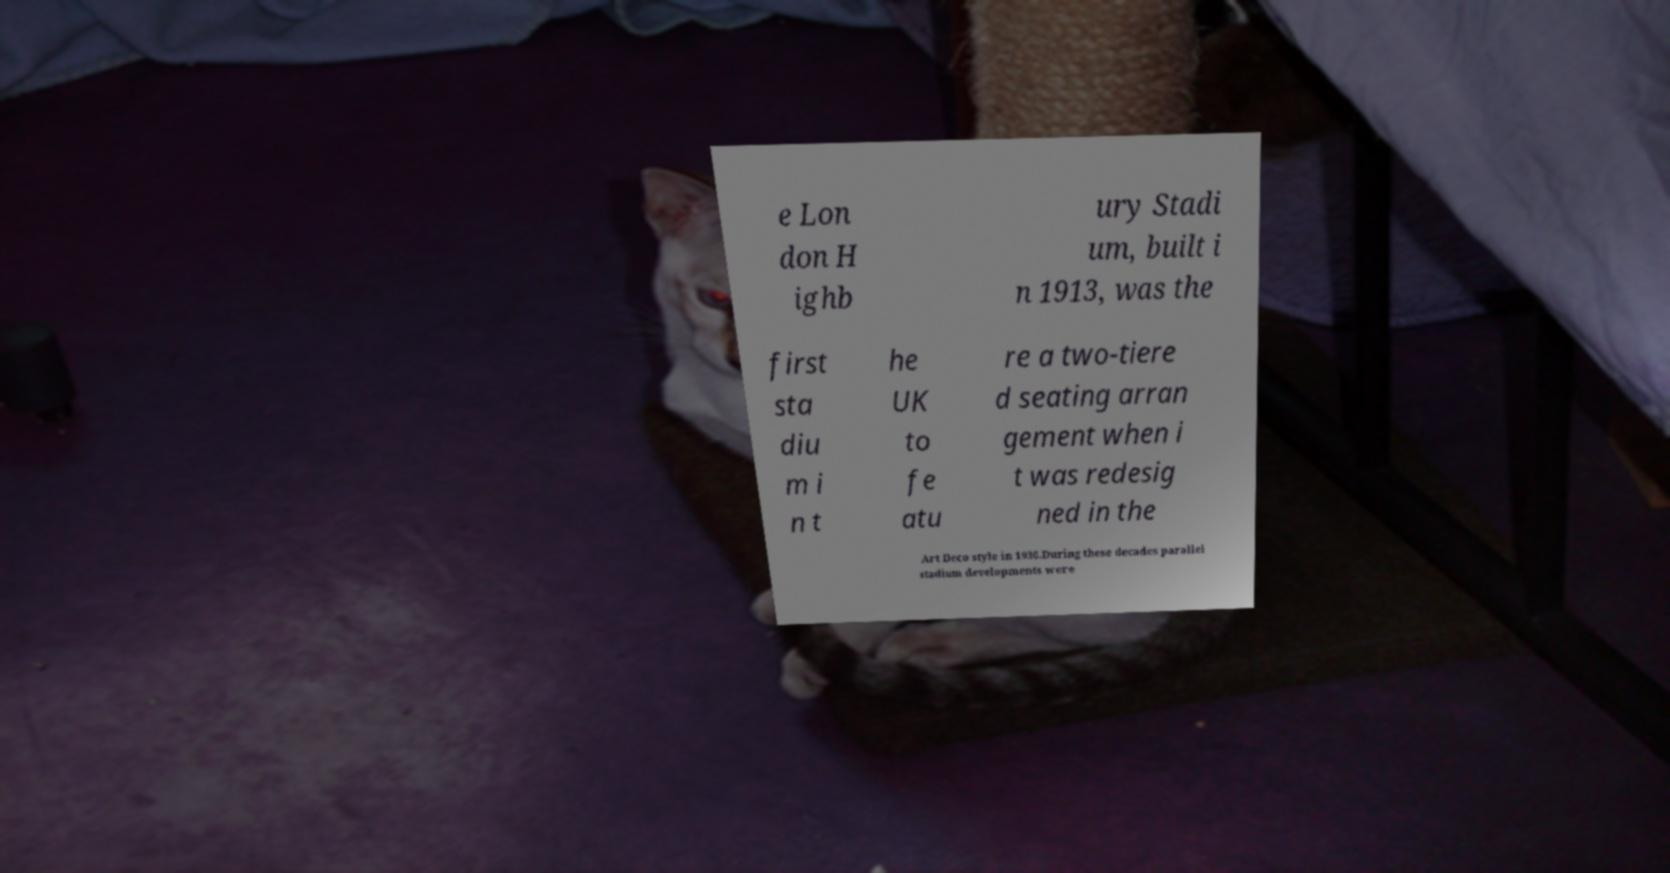Can you read and provide the text displayed in the image?This photo seems to have some interesting text. Can you extract and type it out for me? e Lon don H ighb ury Stadi um, built i n 1913, was the first sta diu m i n t he UK to fe atu re a two-tiere d seating arran gement when i t was redesig ned in the Art Deco style in 1936.During these decades parallel stadium developments were 